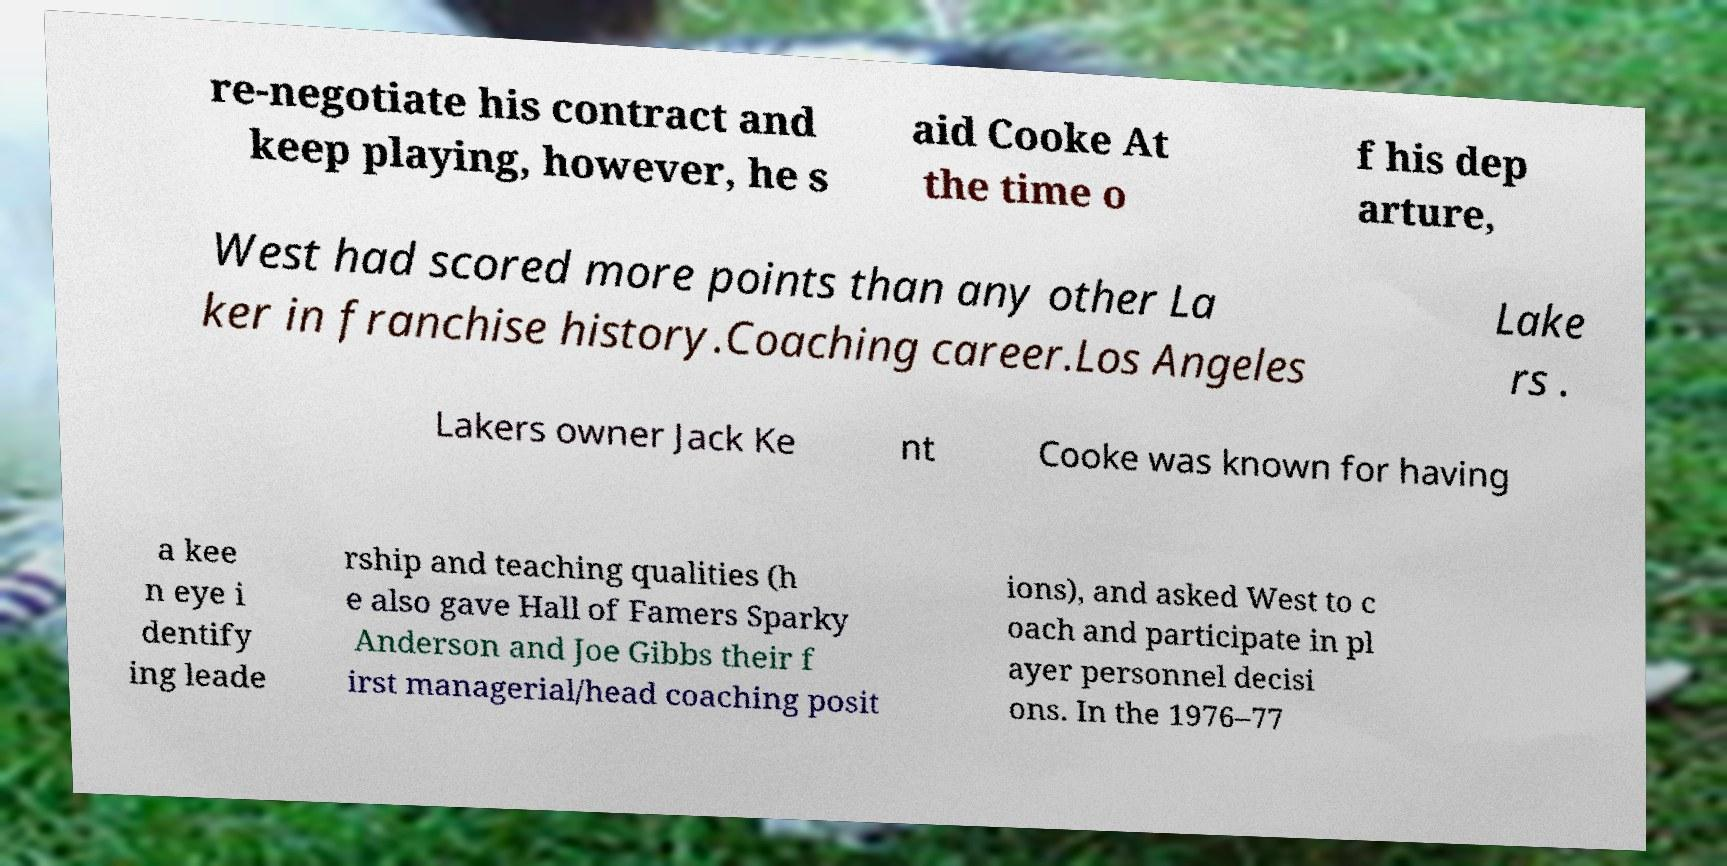Please identify and transcribe the text found in this image. re-negotiate his contract and keep playing, however, he s aid Cooke At the time o f his dep arture, West had scored more points than any other La ker in franchise history.Coaching career.Los Angeles Lake rs . Lakers owner Jack Ke nt Cooke was known for having a kee n eye i dentify ing leade rship and teaching qualities (h e also gave Hall of Famers Sparky Anderson and Joe Gibbs their f irst managerial/head coaching posit ions), and asked West to c oach and participate in pl ayer personnel decisi ons. In the 1976–77 